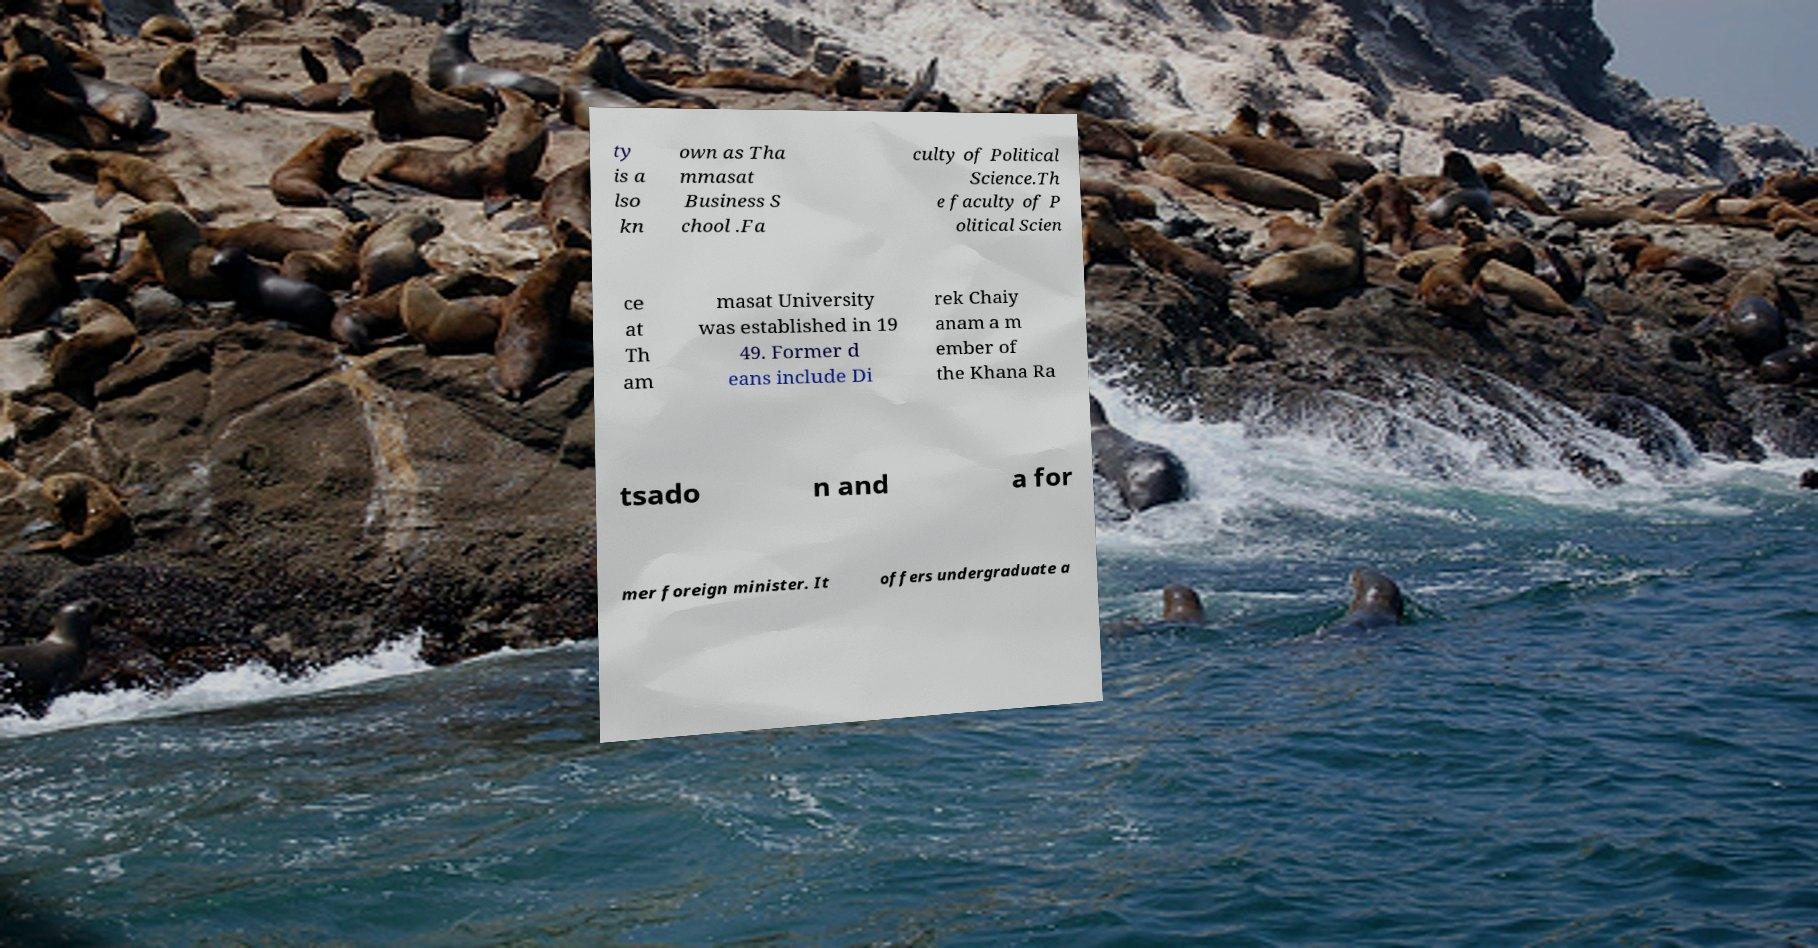Could you extract and type out the text from this image? ty is a lso kn own as Tha mmasat Business S chool .Fa culty of Political Science.Th e faculty of P olitical Scien ce at Th am masat University was established in 19 49. Former d eans include Di rek Chaiy anam a m ember of the Khana Ra tsado n and a for mer foreign minister. It offers undergraduate a 